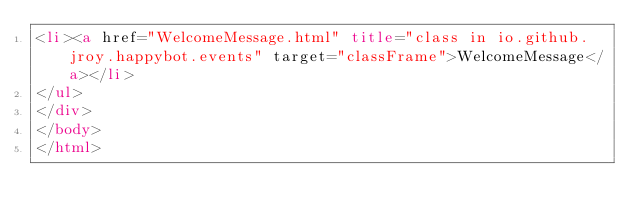<code> <loc_0><loc_0><loc_500><loc_500><_HTML_><li><a href="WelcomeMessage.html" title="class in io.github.jroy.happybot.events" target="classFrame">WelcomeMessage</a></li>
</ul>
</div>
</body>
</html>
</code> 